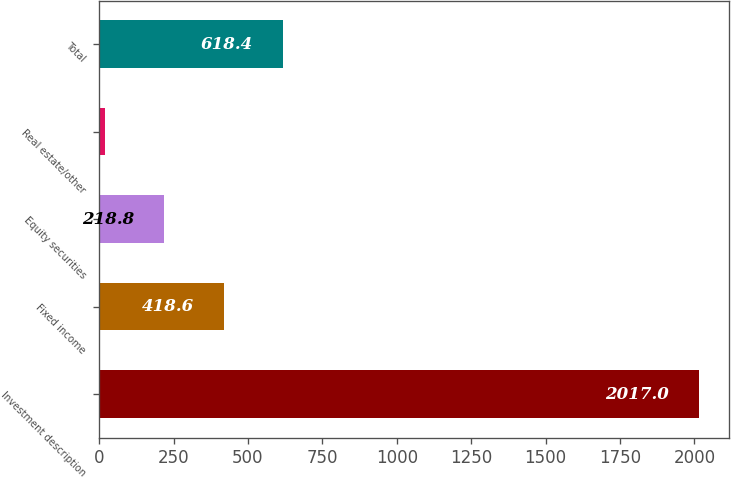Convert chart. <chart><loc_0><loc_0><loc_500><loc_500><bar_chart><fcel>Investment description<fcel>Fixed income<fcel>Equity securities<fcel>Real estate/other<fcel>Total<nl><fcel>2017<fcel>418.6<fcel>218.8<fcel>19<fcel>618.4<nl></chart> 